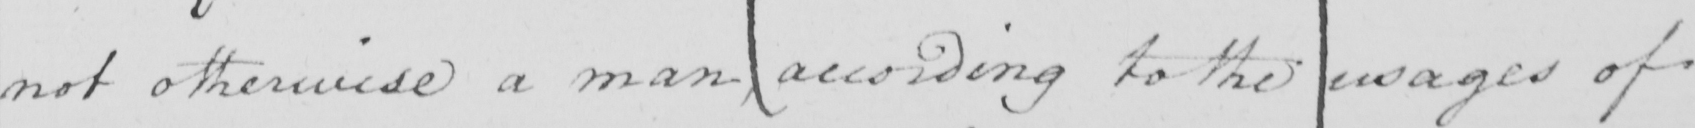Can you read and transcribe this handwriting? not otherwise a man , according to the usages of 